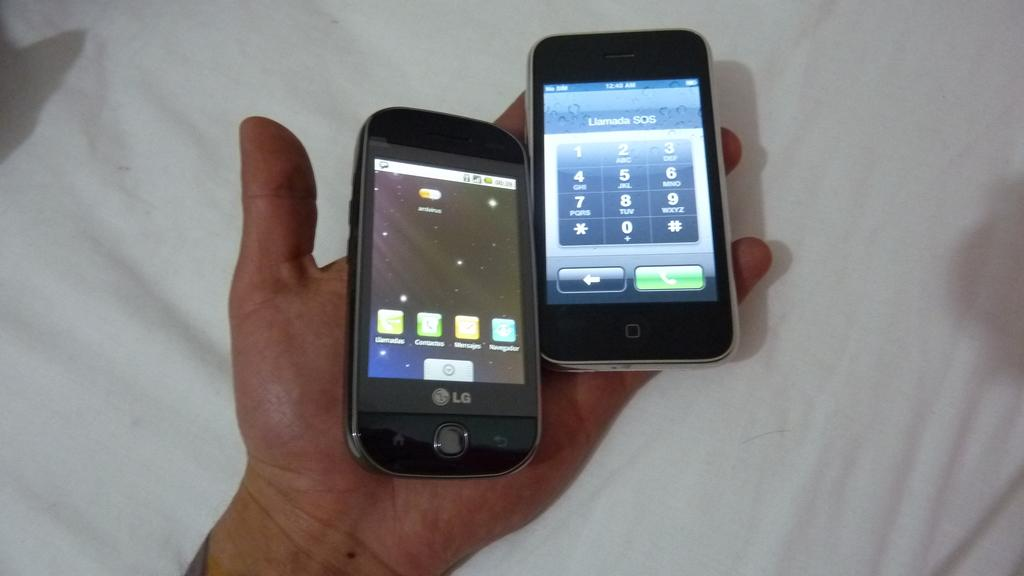<image>
Write a terse but informative summary of the picture. A hand holding an LG branded cell phone and an apple branded iphone. 